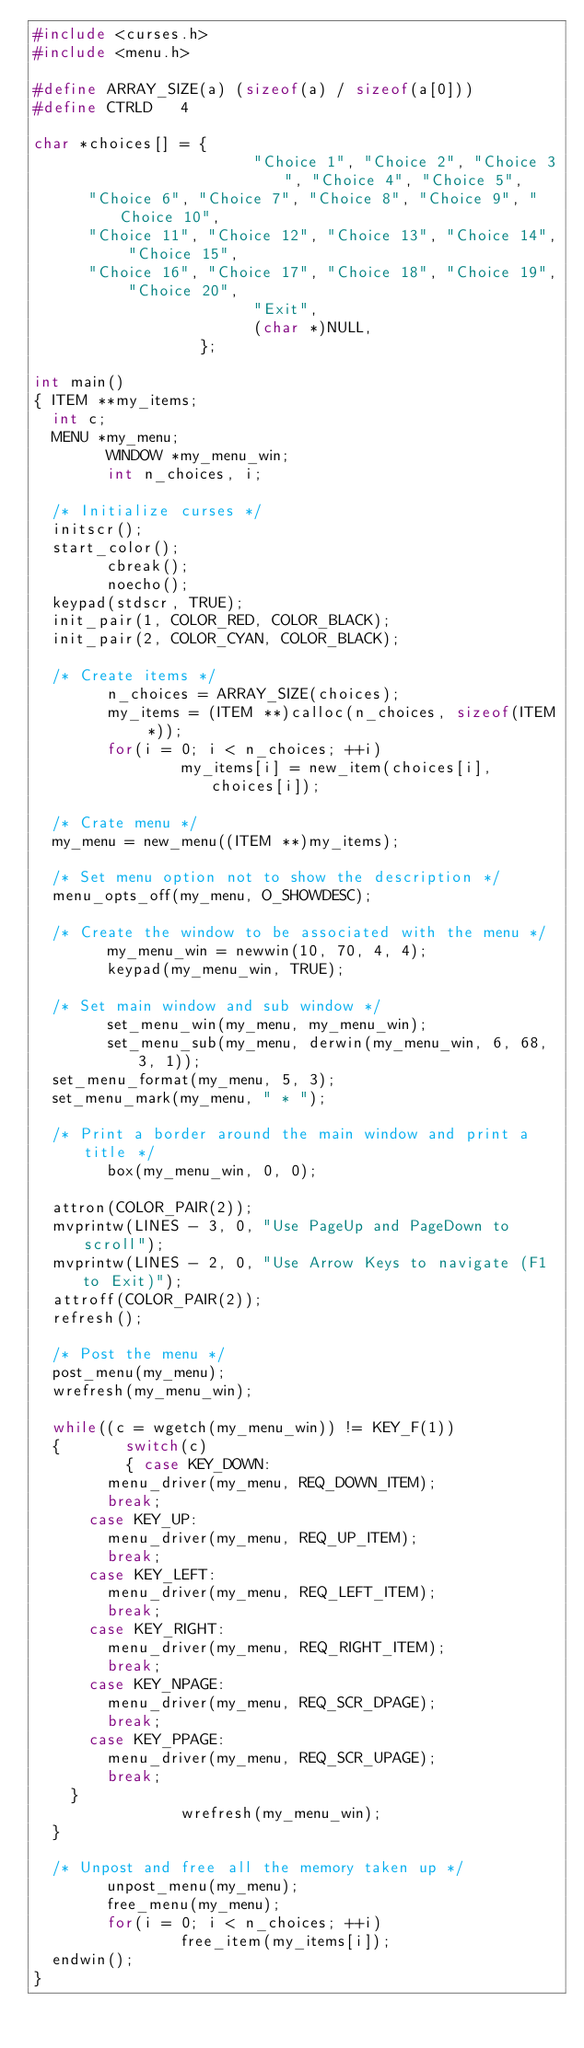Convert code to text. <code><loc_0><loc_0><loc_500><loc_500><_C_>#include <curses.h>
#include <menu.h>

#define ARRAY_SIZE(a) (sizeof(a) / sizeof(a[0]))
#define CTRLD 	4

char *choices[] = {
                        "Choice 1", "Choice 2", "Choice 3", "Choice 4", "Choice 5",
			"Choice 6", "Choice 7", "Choice 8", "Choice 9", "Choice 10",
			"Choice 11", "Choice 12", "Choice 13", "Choice 14", "Choice 15",
			"Choice 16", "Choice 17", "Choice 18", "Choice 19", "Choice 20",
                        "Exit",
                        (char *)NULL,
                  };

int main()
{	ITEM **my_items;
	int c;				
	MENU *my_menu;
        WINDOW *my_menu_win;
        int n_choices, i;
	
	/* Initialize curses */
	initscr();
	start_color();
        cbreak();
        noecho();
	keypad(stdscr, TRUE);
	init_pair(1, COLOR_RED, COLOR_BLACK);
	init_pair(2, COLOR_CYAN, COLOR_BLACK);

	/* Create items */
        n_choices = ARRAY_SIZE(choices);
        my_items = (ITEM **)calloc(n_choices, sizeof(ITEM *));
        for(i = 0; i < n_choices; ++i)
                my_items[i] = new_item(choices[i], choices[i]);

	/* Crate menu */
	my_menu = new_menu((ITEM **)my_items);

	/* Set menu option not to show the description */
	menu_opts_off(my_menu, O_SHOWDESC);

	/* Create the window to be associated with the menu */
        my_menu_win = newwin(10, 70, 4, 4);
        keypad(my_menu_win, TRUE);
     
	/* Set main window and sub window */
        set_menu_win(my_menu, my_menu_win);
        set_menu_sub(my_menu, derwin(my_menu_win, 6, 68, 3, 1));
	set_menu_format(my_menu, 5, 3);
	set_menu_mark(my_menu, " * ");

	/* Print a border around the main window and print a title */
        box(my_menu_win, 0, 0);
	
	attron(COLOR_PAIR(2));
	mvprintw(LINES - 3, 0, "Use PageUp and PageDown to scroll");
	mvprintw(LINES - 2, 0, "Use Arrow Keys to navigate (F1 to Exit)");
	attroff(COLOR_PAIR(2));
	refresh();

	/* Post the menu */
	post_menu(my_menu);
	wrefresh(my_menu_win);
	
	while((c = wgetch(my_menu_win)) != KEY_F(1))
	{       switch(c)
	        {	case KEY_DOWN:
				menu_driver(my_menu, REQ_DOWN_ITEM);
				break;
			case KEY_UP:
				menu_driver(my_menu, REQ_UP_ITEM);
				break;
			case KEY_LEFT:
				menu_driver(my_menu, REQ_LEFT_ITEM);
				break;
			case KEY_RIGHT:
				menu_driver(my_menu, REQ_RIGHT_ITEM);
				break;
			case KEY_NPAGE:
				menu_driver(my_menu, REQ_SCR_DPAGE);
				break;
			case KEY_PPAGE:
				menu_driver(my_menu, REQ_SCR_UPAGE);
				break;
		}
                wrefresh(my_menu_win);
	}	

	/* Unpost and free all the memory taken up */
        unpost_menu(my_menu);
        free_menu(my_menu);
        for(i = 0; i < n_choices; ++i)
                free_item(my_items[i]);
	endwin();
}
</code> 